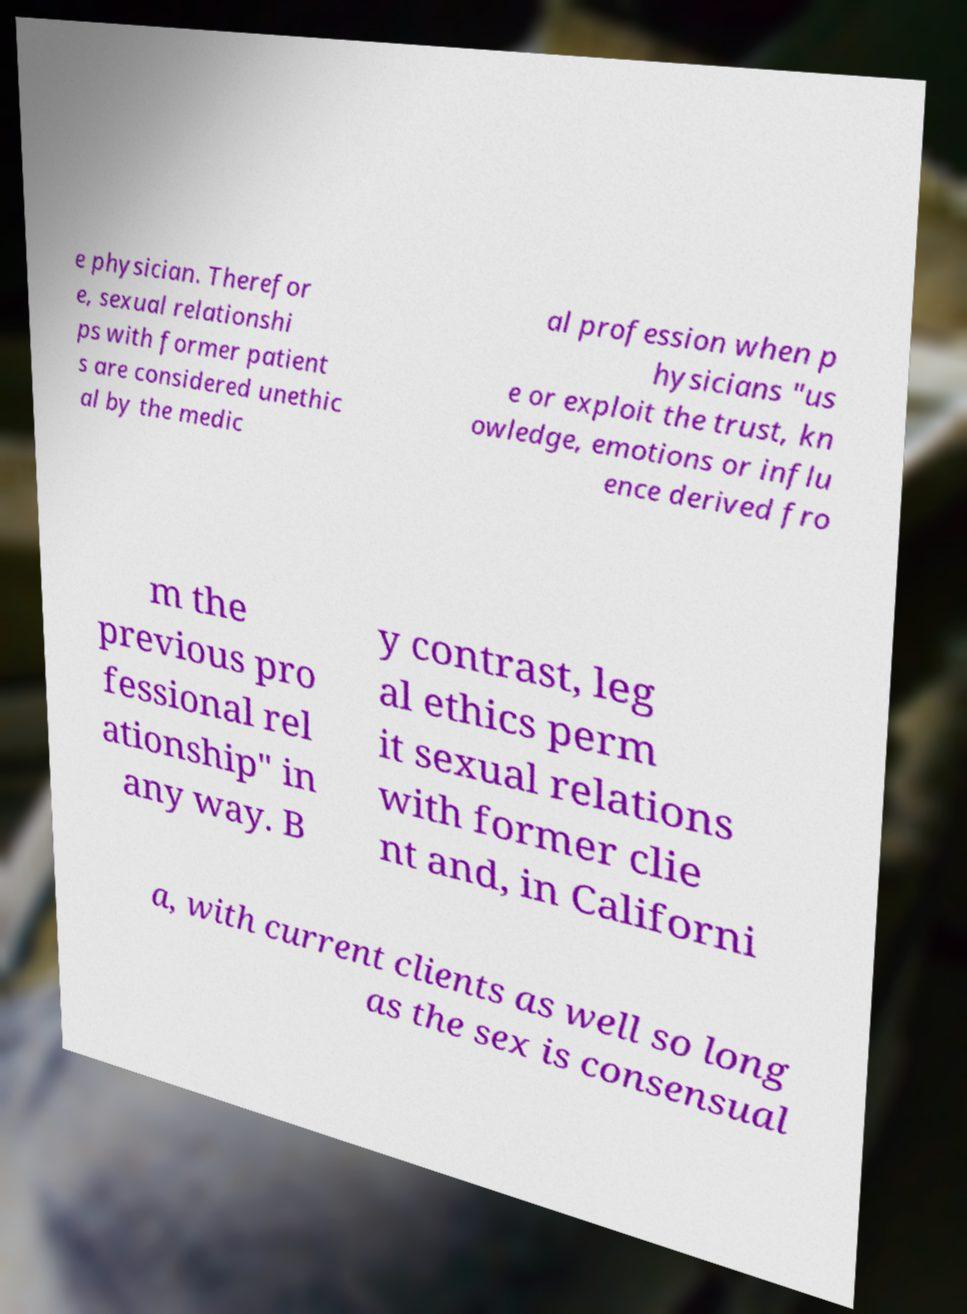What messages or text are displayed in this image? I need them in a readable, typed format. e physician. Therefor e, sexual relationshi ps with former patient s are considered unethic al by the medic al profession when p hysicians "us e or exploit the trust, kn owledge, emotions or influ ence derived fro m the previous pro fessional rel ationship" in any way. B y contrast, leg al ethics perm it sexual relations with former clie nt and, in Californi a, with current clients as well so long as the sex is consensual 